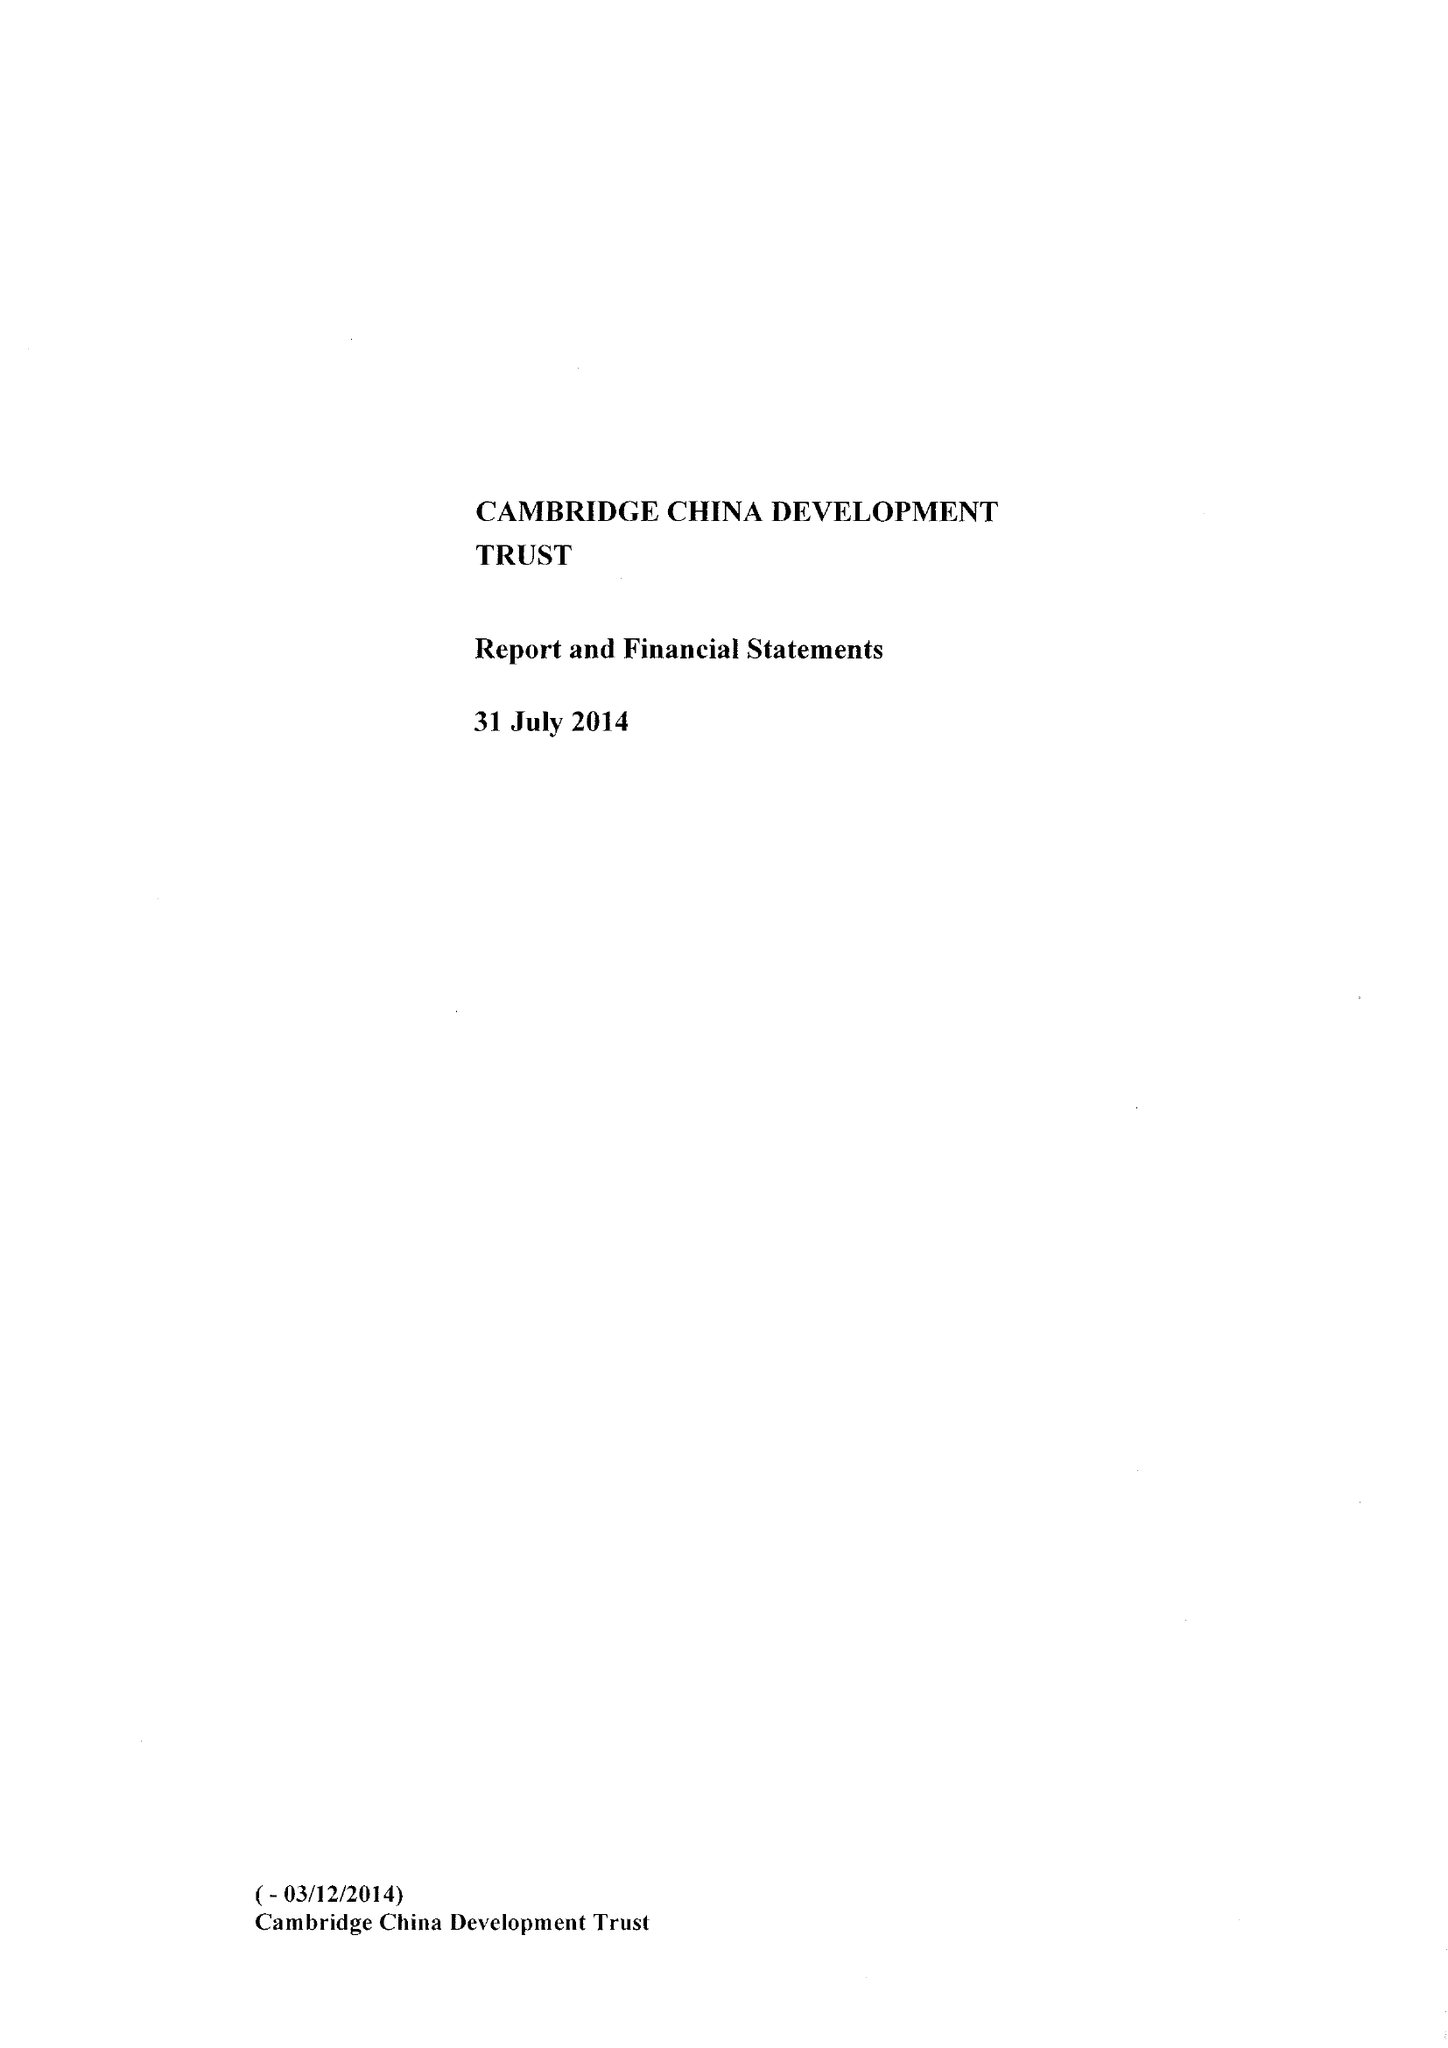What is the value for the charity_name?
Answer the question using a single word or phrase. The Cambridge China Development Trust 